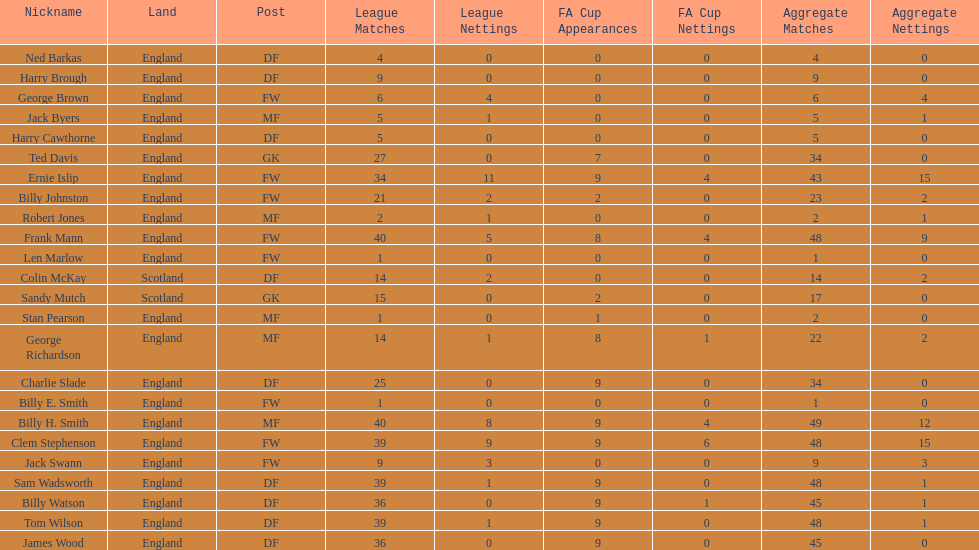Write the full table. {'header': ['Nickname', 'Land', 'Post', 'League Matches', 'League Nettings', 'FA Cup Appearances', 'FA Cup Nettings', 'Aggregate Matches', 'Aggregate Nettings'], 'rows': [['Ned Barkas', 'England', 'DF', '4', '0', '0', '0', '4', '0'], ['Harry Brough', 'England', 'DF', '9', '0', '0', '0', '9', '0'], ['George Brown', 'England', 'FW', '6', '4', '0', '0', '6', '4'], ['Jack Byers', 'England', 'MF', '5', '1', '0', '0', '5', '1'], ['Harry Cawthorne', 'England', 'DF', '5', '0', '0', '0', '5', '0'], ['Ted Davis', 'England', 'GK', '27', '0', '7', '0', '34', '0'], ['Ernie Islip', 'England', 'FW', '34', '11', '9', '4', '43', '15'], ['Billy Johnston', 'England', 'FW', '21', '2', '2', '0', '23', '2'], ['Robert Jones', 'England', 'MF', '2', '1', '0', '0', '2', '1'], ['Frank Mann', 'England', 'FW', '40', '5', '8', '4', '48', '9'], ['Len Marlow', 'England', 'FW', '1', '0', '0', '0', '1', '0'], ['Colin McKay', 'Scotland', 'DF', '14', '2', '0', '0', '14', '2'], ['Sandy Mutch', 'Scotland', 'GK', '15', '0', '2', '0', '17', '0'], ['Stan Pearson', 'England', 'MF', '1', '0', '1', '0', '2', '0'], ['George Richardson', 'England', 'MF', '14', '1', '8', '1', '22', '2'], ['Charlie Slade', 'England', 'DF', '25', '0', '9', '0', '34', '0'], ['Billy E. Smith', 'England', 'FW', '1', '0', '0', '0', '1', '0'], ['Billy H. Smith', 'England', 'MF', '40', '8', '9', '4', '49', '12'], ['Clem Stephenson', 'England', 'FW', '39', '9', '9', '6', '48', '15'], ['Jack Swann', 'England', 'FW', '9', '3', '0', '0', '9', '3'], ['Sam Wadsworth', 'England', 'DF', '39', '1', '9', '0', '48', '1'], ['Billy Watson', 'England', 'DF', '36', '0', '9', '1', '45', '1'], ['Tom Wilson', 'England', 'DF', '39', '1', '9', '0', '48', '1'], ['James Wood', 'England', 'DF', '36', '0', '9', '0', '45', '0']]} Name the nation with the most appearances. England. 